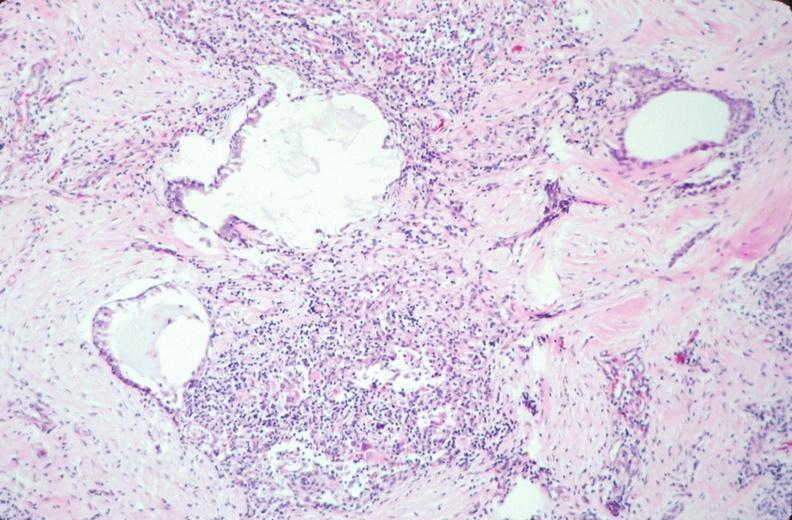what is present?
Answer the question using a single word or phrase. Embryo-fetus 